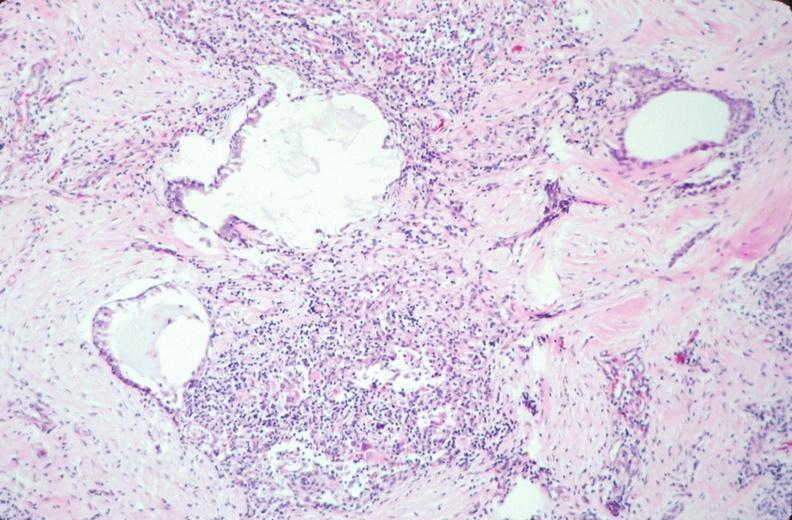what is present?
Answer the question using a single word or phrase. Embryo-fetus 